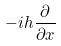<formula> <loc_0><loc_0><loc_500><loc_500>- i h \frac { \partial } { \partial x }</formula> 